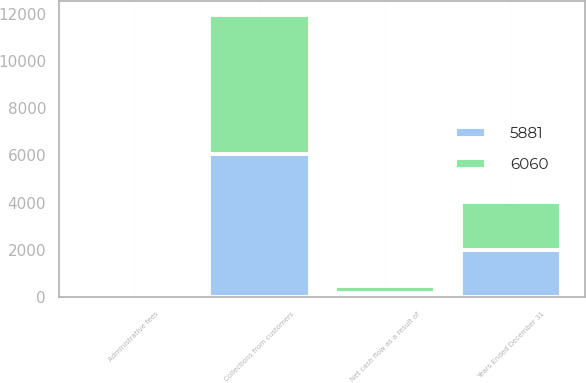<chart> <loc_0><loc_0><loc_500><loc_500><stacked_bar_chart><ecel><fcel>Years Ended December 31<fcel>Administrative fees<fcel>Net cash flow as a result of<fcel>Collections from customers<nl><fcel>5881<fcel>2008<fcel>1<fcel>170<fcel>6060<nl><fcel>6060<fcel>2007<fcel>3<fcel>325<fcel>5881<nl></chart> 